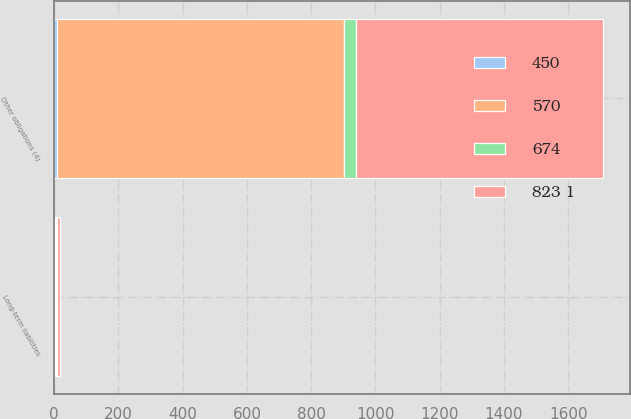Convert chart. <chart><loc_0><loc_0><loc_500><loc_500><stacked_bar_chart><ecel><fcel>Long-term liabilities<fcel>Other obligations (4)<nl><fcel>823 1<fcel>8<fcel>767<nl><fcel>570<fcel>3<fcel>893<nl><fcel>674<fcel>3<fcel>38<nl><fcel>450<fcel>3<fcel>9<nl></chart> 